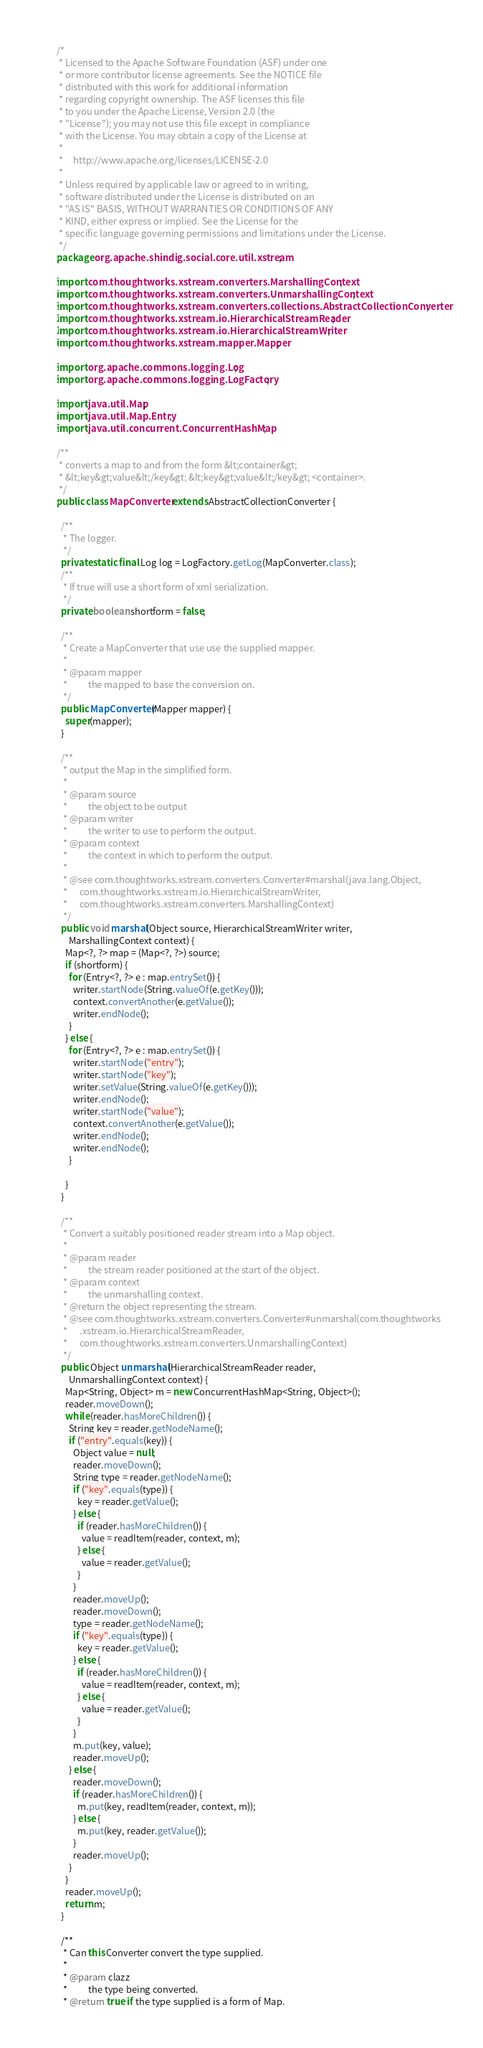<code> <loc_0><loc_0><loc_500><loc_500><_Java_>/*
 * Licensed to the Apache Software Foundation (ASF) under one
 * or more contributor license agreements. See the NOTICE file
 * distributed with this work for additional information
 * regarding copyright ownership. The ASF licenses this file
 * to you under the Apache License, Version 2.0 (the
 * "License"); you may not use this file except in compliance
 * with the License. You may obtain a copy of the License at
 *
 *     http://www.apache.org/licenses/LICENSE-2.0
 *
 * Unless required by applicable law or agreed to in writing,
 * software distributed under the License is distributed on an
 * "AS IS" BASIS, WITHOUT WARRANTIES OR CONDITIONS OF ANY
 * KIND, either express or implied. See the License for the
 * specific language governing permissions and limitations under the License.
 */
package org.apache.shindig.social.core.util.xstream;

import com.thoughtworks.xstream.converters.MarshallingContext;
import com.thoughtworks.xstream.converters.UnmarshallingContext;
import com.thoughtworks.xstream.converters.collections.AbstractCollectionConverter;
import com.thoughtworks.xstream.io.HierarchicalStreamReader;
import com.thoughtworks.xstream.io.HierarchicalStreamWriter;
import com.thoughtworks.xstream.mapper.Mapper;

import org.apache.commons.logging.Log;
import org.apache.commons.logging.LogFactory;

import java.util.Map;
import java.util.Map.Entry;
import java.util.concurrent.ConcurrentHashMap;

/**
 * converts a map to and from the form &lt;container&gt;
 * &lt;key&gt;value&lt;/key&gt; &lt;key&gt;value&lt;/key&gt; <container>.
 */
public class MapConverter extends AbstractCollectionConverter {

  /**
   * The logger.
   */
  private static final Log log = LogFactory.getLog(MapConverter.class);
  /**
   * If true will use a short form of xml serialization.
   */
  private boolean shortform = false;

  /**
   * Create a MapConverter that use use the supplied mapper.
   *
   * @param mapper
   *          the mapped to base the conversion on.
   */
  public MapConverter(Mapper mapper) {
    super(mapper);
  }

  /**
   * output the Map in the simplified form.
   *
   * @param source
   *          the object to be output
   * @param writer
   *          the writer to use to perform the output.
   * @param context
   *          the context in which to perform the output.
   *
   * @see com.thoughtworks.xstream.converters.Converter#marshal(java.lang.Object,
   *      com.thoughtworks.xstream.io.HierarchicalStreamWriter,
   *      com.thoughtworks.xstream.converters.MarshallingContext)
   */
  public void marshal(Object source, HierarchicalStreamWriter writer,
      MarshallingContext context) {
    Map<?, ?> map = (Map<?, ?>) source;
    if (shortform) {
      for (Entry<?, ?> e : map.entrySet()) {
        writer.startNode(String.valueOf(e.getKey()));
        context.convertAnother(e.getValue());
        writer.endNode();
      }
    } else {
      for (Entry<?, ?> e : map.entrySet()) {
        writer.startNode("entry");
        writer.startNode("key");
        writer.setValue(String.valueOf(e.getKey()));
        writer.endNode();
        writer.startNode("value");
        context.convertAnother(e.getValue());
        writer.endNode();
        writer.endNode();
      }

    }
  }

  /**
   * Convert a suitably positioned reader stream into a Map object.
   *
   * @param reader
   *          the stream reader positioned at the start of the object.
   * @param context
   *          the unmarshalling context.
   * @return the object representing the stream.
   * @see com.thoughtworks.xstream.converters.Converter#unmarshal(com.thoughtworks
   *      .xstream.io.HierarchicalStreamReader,
   *      com.thoughtworks.xstream.converters.UnmarshallingContext)
   */
  public Object unmarshal(HierarchicalStreamReader reader,
      UnmarshallingContext context) {
    Map<String, Object> m = new ConcurrentHashMap<String, Object>();
    reader.moveDown();
    while (reader.hasMoreChildren()) {
      String key = reader.getNodeName();
      if ("entry".equals(key)) {
        Object value = null;
        reader.moveDown();
        String type = reader.getNodeName();
        if ("key".equals(type)) {
          key = reader.getValue();
        } else {
          if (reader.hasMoreChildren()) {
            value = readItem(reader, context, m);
          } else {
            value = reader.getValue();
          }
        }
        reader.moveUp();
        reader.moveDown();
        type = reader.getNodeName();
        if ("key".equals(type)) {
          key = reader.getValue();
        } else {
          if (reader.hasMoreChildren()) {
            value = readItem(reader, context, m);
          } else {
            value = reader.getValue();
          }
        }
        m.put(key, value);
        reader.moveUp();
      } else {
        reader.moveDown();
        if (reader.hasMoreChildren()) {
          m.put(key, readItem(reader, context, m));
        } else {
          m.put(key, reader.getValue());
        }
        reader.moveUp();
      }
    }
    reader.moveUp();
    return m;
  }

  /**
   * Can this Converter convert the type supplied.
   *
   * @param clazz
   *          the type being converted.
   * @return true if the type supplied is a form of Map.</code> 